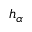Convert formula to latex. <formula><loc_0><loc_0><loc_500><loc_500>h _ { \alpha }</formula> 